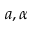Convert formula to latex. <formula><loc_0><loc_0><loc_500><loc_500>a , \alpha</formula> 